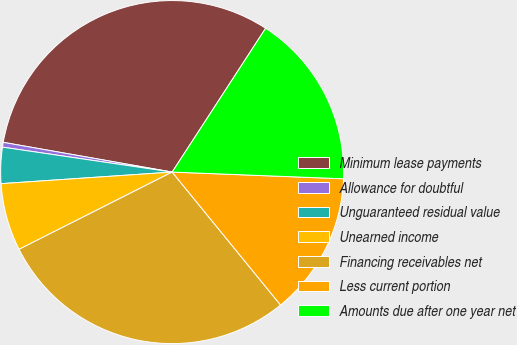<chart> <loc_0><loc_0><loc_500><loc_500><pie_chart><fcel>Minimum lease payments<fcel>Allowance for doubtful<fcel>Unguaranteed residual value<fcel>Unearned income<fcel>Financing receivables net<fcel>Less current portion<fcel>Amounts due after one year net<nl><fcel>31.4%<fcel>0.45%<fcel>3.4%<fcel>6.36%<fcel>28.45%<fcel>13.49%<fcel>16.45%<nl></chart> 